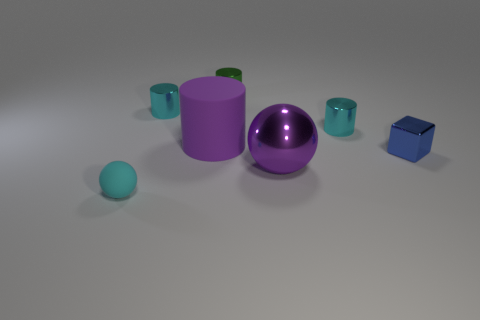What is the arrangement of the objects relative to one another? The objects are grouped together near the center of the image. The purple cylinder and sphere are central and prominent. The cyan objects, resembling cups, are positioned around the purple sphere, with some closer to the cylinder. The small blue cube is set apart slightly to the right. 